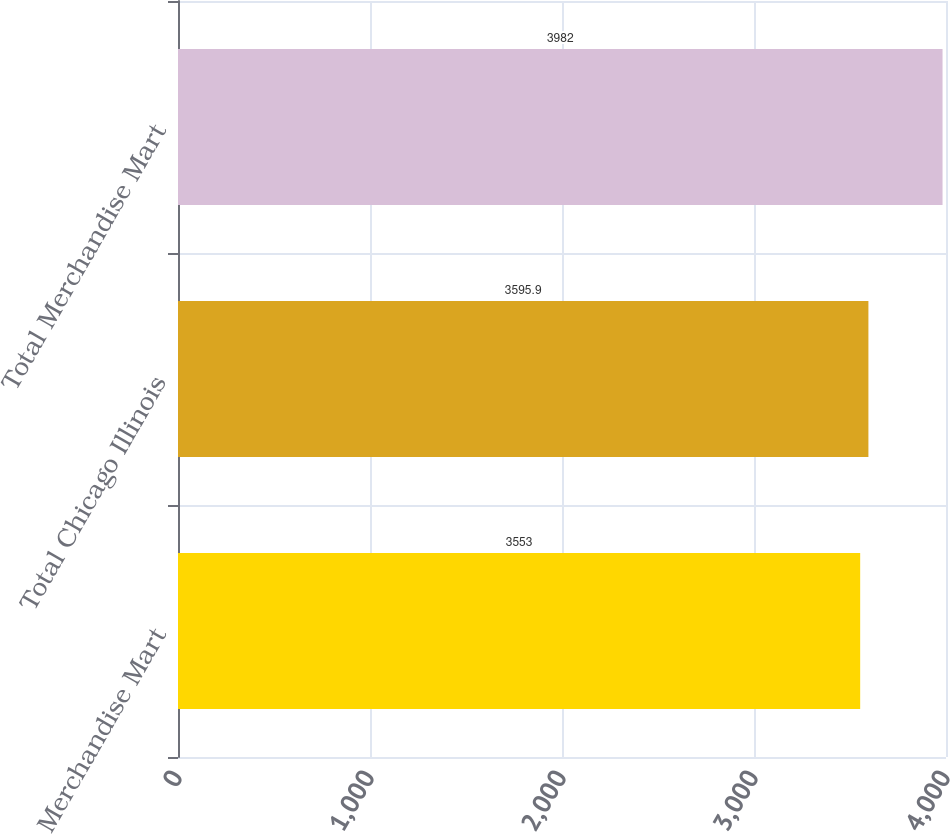Convert chart. <chart><loc_0><loc_0><loc_500><loc_500><bar_chart><fcel>Merchandise Mart<fcel>Total Chicago Illinois<fcel>Total Merchandise Mart<nl><fcel>3553<fcel>3595.9<fcel>3982<nl></chart> 